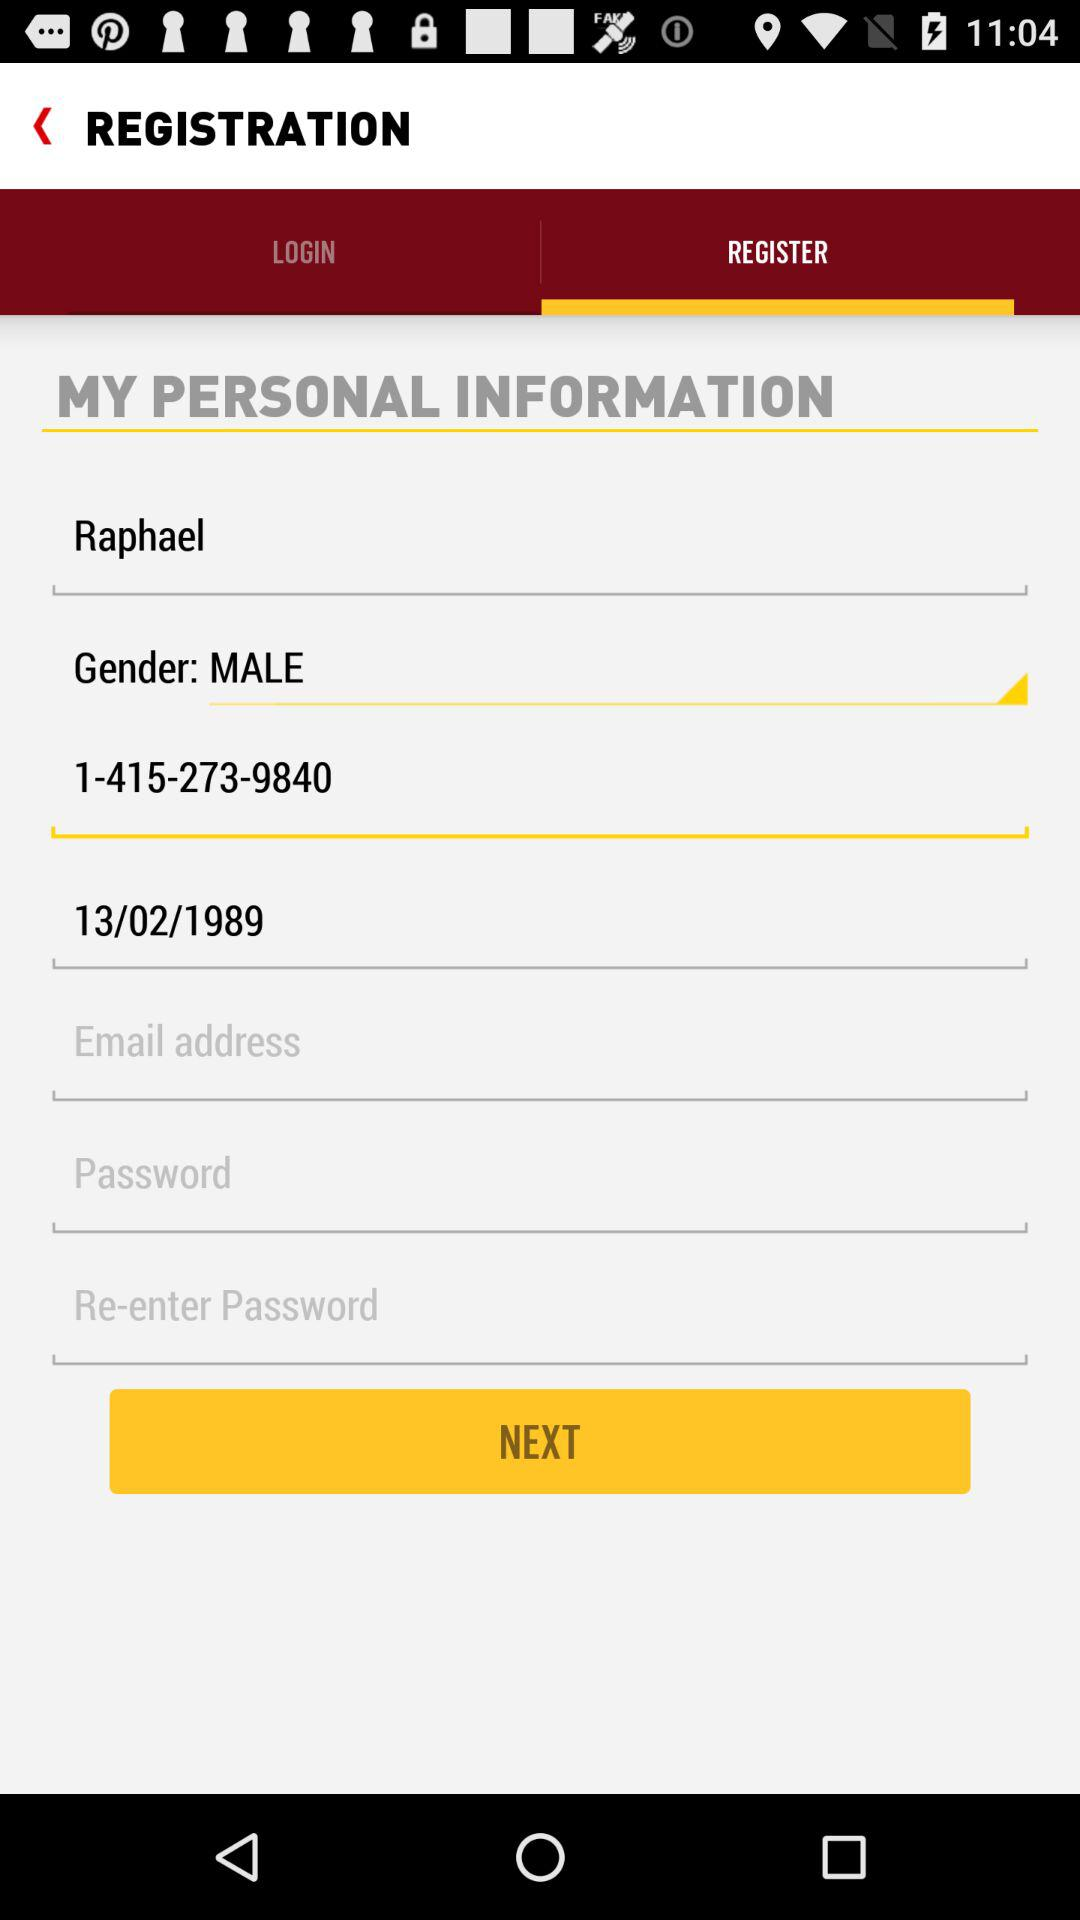Which option is selected in the "Gender" field? The selected option is "MALE". 